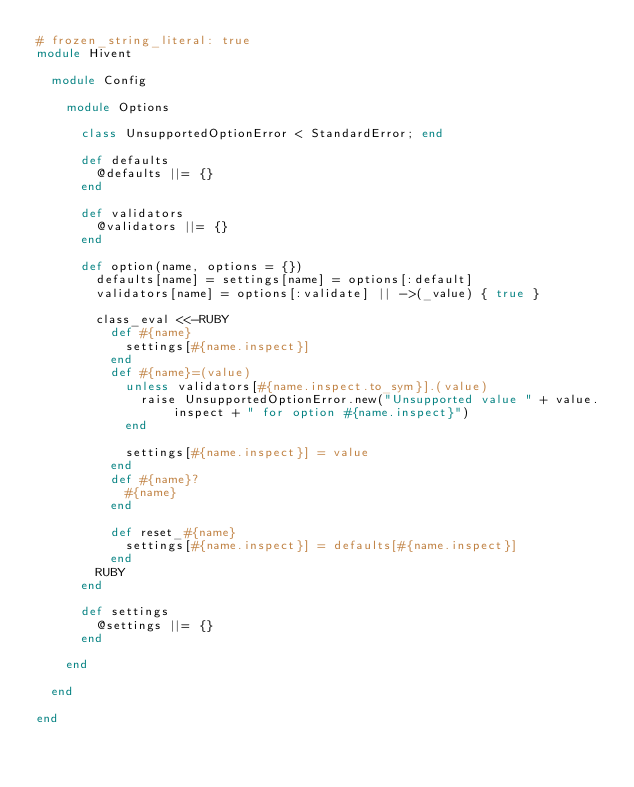<code> <loc_0><loc_0><loc_500><loc_500><_Ruby_># frozen_string_literal: true
module Hivent

  module Config

    module Options

      class UnsupportedOptionError < StandardError; end

      def defaults
        @defaults ||= {}
      end

      def validators
        @validators ||= {}
      end

      def option(name, options = {})
        defaults[name] = settings[name] = options[:default]
        validators[name] = options[:validate] || ->(_value) { true }

        class_eval <<-RUBY
          def #{name}
            settings[#{name.inspect}]
          end
          def #{name}=(value)
            unless validators[#{name.inspect.to_sym}].(value)
              raise UnsupportedOptionError.new("Unsupported value " + value.inspect + " for option #{name.inspect}")
            end

            settings[#{name.inspect}] = value
          end
          def #{name}?
            #{name}
          end

          def reset_#{name}
            settings[#{name.inspect}] = defaults[#{name.inspect}]
          end
        RUBY
      end

      def settings
        @settings ||= {}
      end

    end

  end

end
</code> 